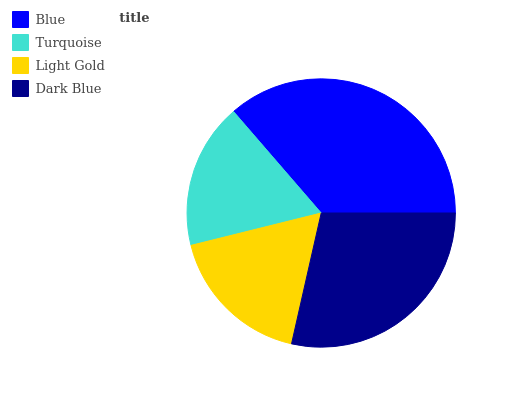Is Turquoise the minimum?
Answer yes or no. Yes. Is Blue the maximum?
Answer yes or no. Yes. Is Light Gold the minimum?
Answer yes or no. No. Is Light Gold the maximum?
Answer yes or no. No. Is Light Gold greater than Turquoise?
Answer yes or no. Yes. Is Turquoise less than Light Gold?
Answer yes or no. Yes. Is Turquoise greater than Light Gold?
Answer yes or no. No. Is Light Gold less than Turquoise?
Answer yes or no. No. Is Dark Blue the high median?
Answer yes or no. Yes. Is Light Gold the low median?
Answer yes or no. Yes. Is Light Gold the high median?
Answer yes or no. No. Is Turquoise the low median?
Answer yes or no. No. 